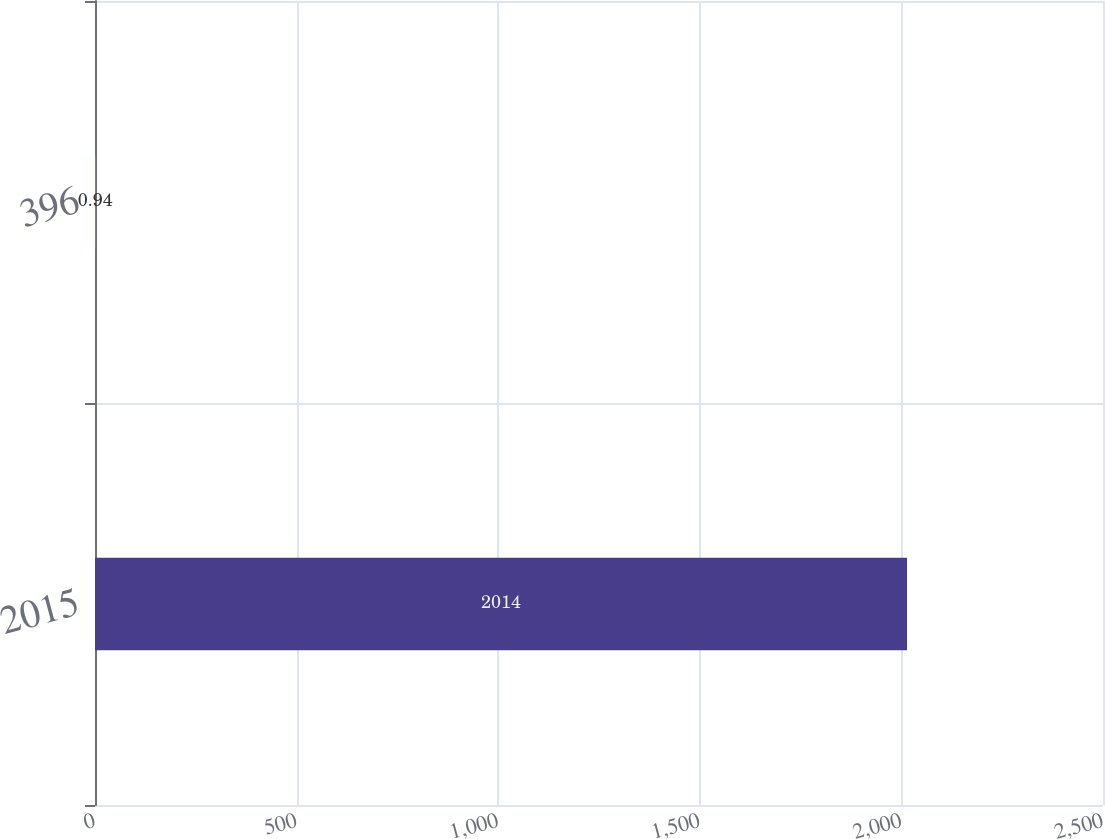Convert chart. <chart><loc_0><loc_0><loc_500><loc_500><bar_chart><fcel>2015<fcel>396<nl><fcel>2014<fcel>0.94<nl></chart> 